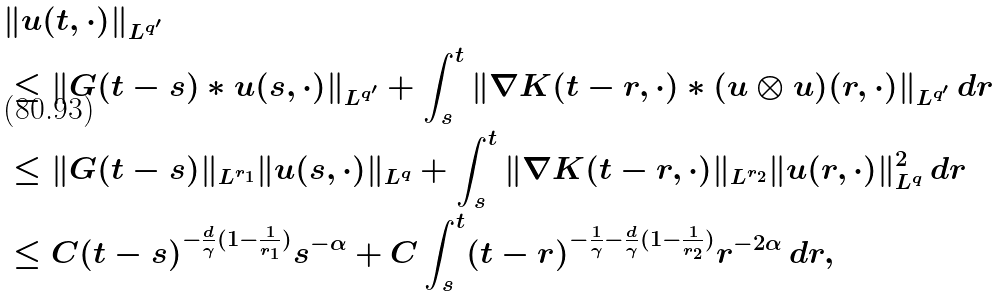Convert formula to latex. <formula><loc_0><loc_0><loc_500><loc_500>& \| u ( t , \cdot ) \| _ { L ^ { q ^ { \prime } } } \\ & \leq \| G ( t - s ) * u ( s , \cdot ) \| _ { L ^ { q ^ { \prime } } } + \int _ { s } ^ { t } \| \nabla K ( t - r , \cdot ) * ( u \otimes u ) ( r , \cdot ) \| _ { L ^ { q ^ { \prime } } } \, d r \\ & \leq \| G ( t - s ) \| _ { L ^ { r _ { 1 } } } \| u ( s , \cdot ) \| _ { L ^ { q } } + \int _ { s } ^ { t } \| \nabla K ( t - r , \cdot ) \| _ { L ^ { r _ { 2 } } } \| u ( r , \cdot ) \| ^ { 2 } _ { L ^ { q } } \, d r \\ & \leq C ( t - s ) ^ { - \frac { d } { \gamma } ( 1 - \frac { 1 } { r _ { 1 } } ) } s ^ { - \alpha } + C \int _ { s } ^ { t } ( t - r ) ^ { - \frac { 1 } { \gamma } - \frac { d } { \gamma } ( 1 - \frac { 1 } { r _ { 2 } } ) } r ^ { - 2 \alpha } \, d r ,</formula> 